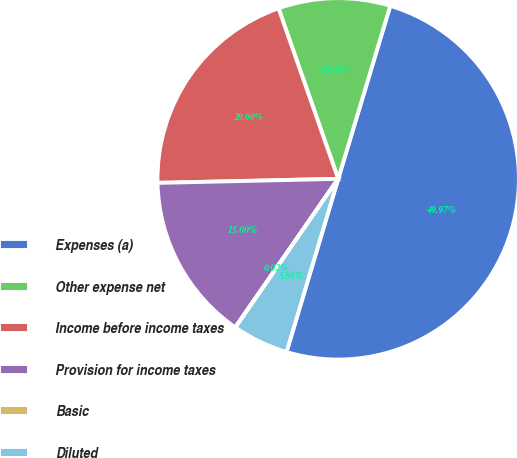<chart> <loc_0><loc_0><loc_500><loc_500><pie_chart><fcel>Expenses (a)<fcel>Other expense net<fcel>Income before income taxes<fcel>Provision for income taxes<fcel>Basic<fcel>Diluted<nl><fcel>49.97%<fcel>10.01%<fcel>20.0%<fcel>15.0%<fcel>0.02%<fcel>5.01%<nl></chart> 